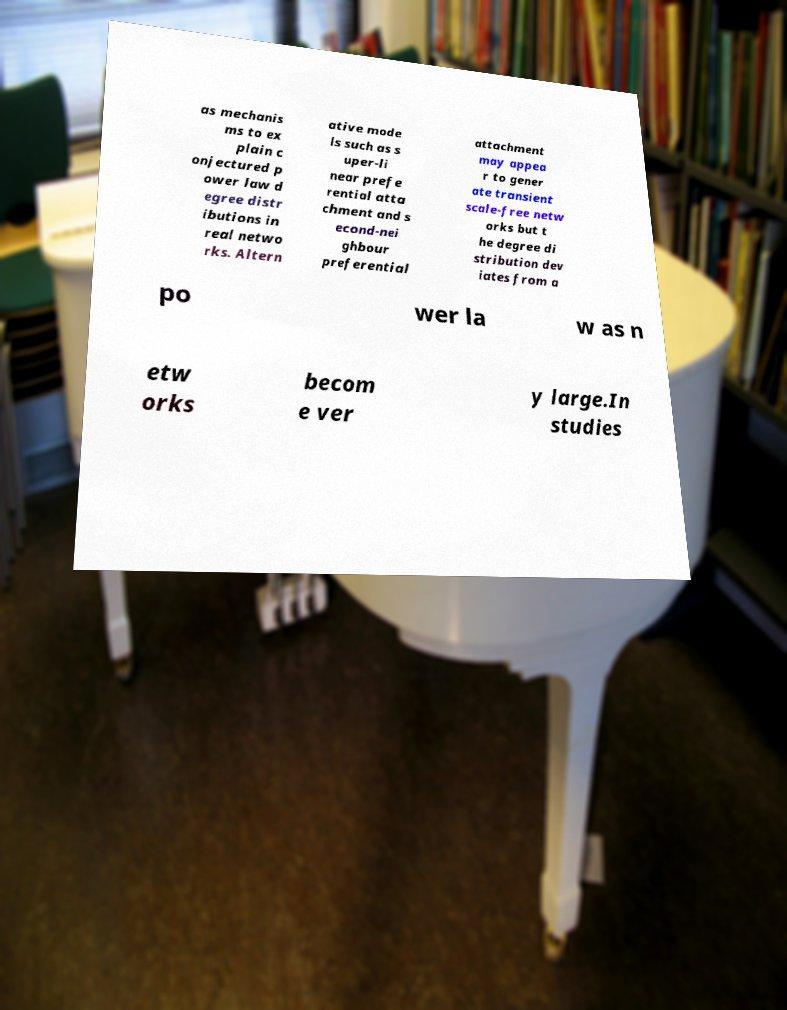Please read and relay the text visible in this image. What does it say? as mechanis ms to ex plain c onjectured p ower law d egree distr ibutions in real netwo rks. Altern ative mode ls such as s uper-li near prefe rential atta chment and s econd-nei ghbour preferential attachment may appea r to gener ate transient scale-free netw orks but t he degree di stribution dev iates from a po wer la w as n etw orks becom e ver y large.In studies 